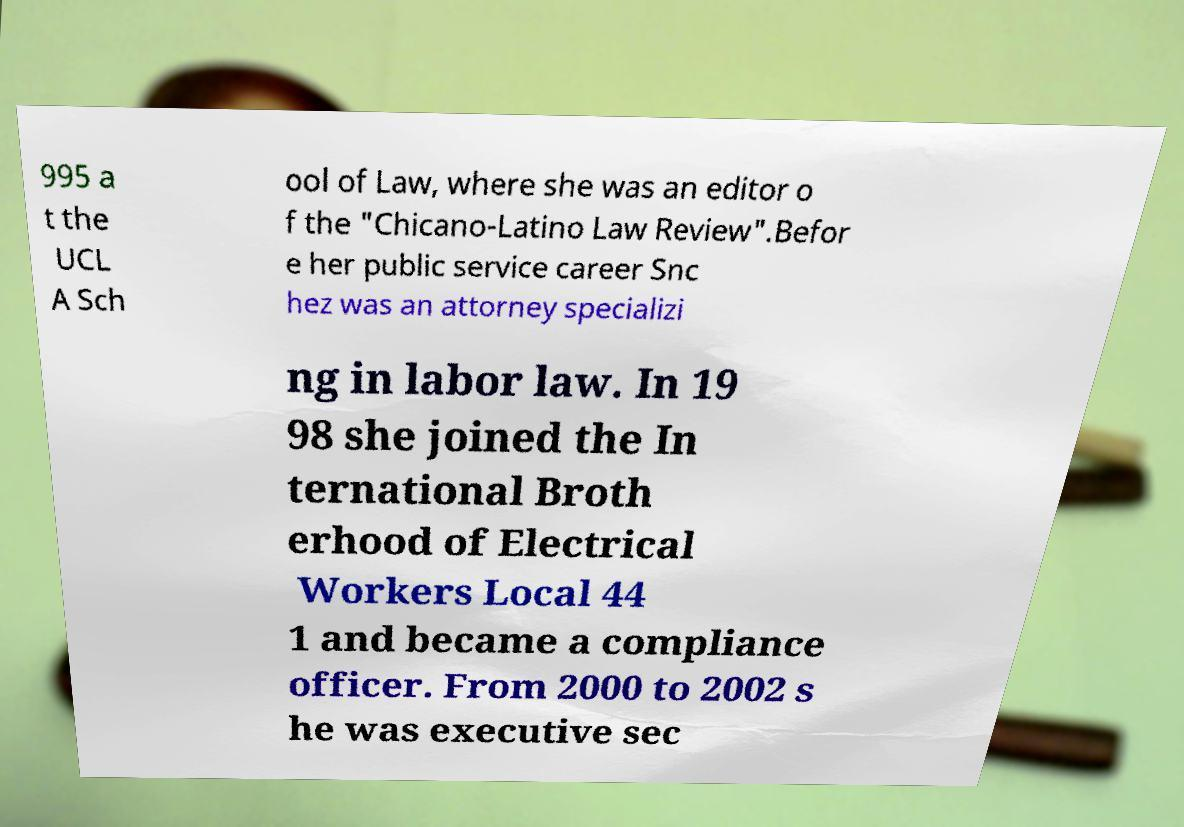Please identify and transcribe the text found in this image. 995 a t the UCL A Sch ool of Law, where she was an editor o f the "Chicano-Latino Law Review".Befor e her public service career Snc hez was an attorney specializi ng in labor law. In 19 98 she joined the In ternational Broth erhood of Electrical Workers Local 44 1 and became a compliance officer. From 2000 to 2002 s he was executive sec 